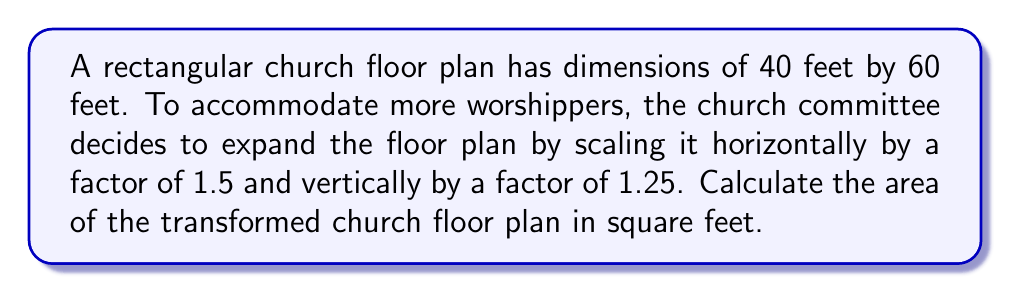Give your solution to this math problem. Let's approach this step-by-step:

1) First, let's identify the original dimensions:
   Length (L) = 60 feet
   Width (W) = 40 feet

2) The transformation applied:
   Horizontal scaling: 1.5
   Vertical scaling: 1.25

3) Calculate the new dimensions:
   New Length = L * 1.5 = 60 * 1.5 = 90 feet
   New Width = W * 1.25 = 40 * 1.25 = 50 feet

4) The area of a rectangle is given by the formula:
   $$A = L * W$$

5) Substitute the new dimensions into the formula:
   $$A = 90 * 50$$

6) Calculate the final area:
   $$A = 4500$$ square feet

Therefore, the area of the transformed church floor plan is 4500 square feet.
Answer: 4500 sq ft 